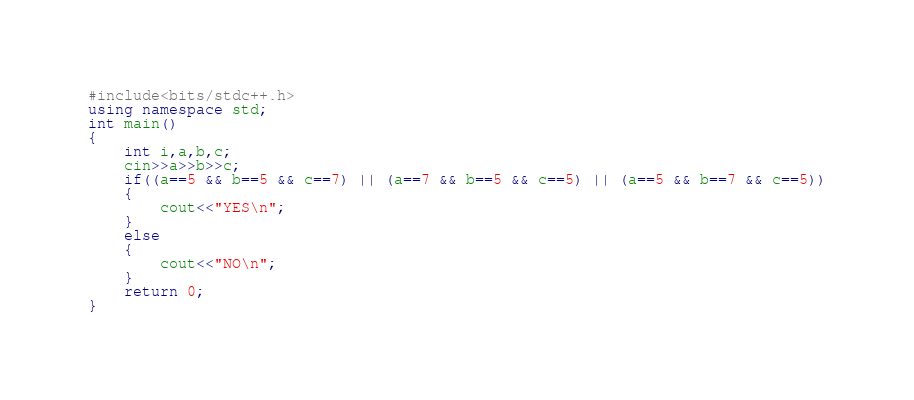Convert code to text. <code><loc_0><loc_0><loc_500><loc_500><_C++_>#include<bits/stdc++.h>
using namespace std;
int main()
{
    int i,a,b,c;
    cin>>a>>b>>c;
    if((a==5 && b==5 && c==7) || (a==7 && b==5 && c==5) || (a==5 && b==7 && c==5))
    {
        cout<<"YES\n";
    }
    else
    {
        cout<<"NO\n";
    }
    return 0;
}
</code> 